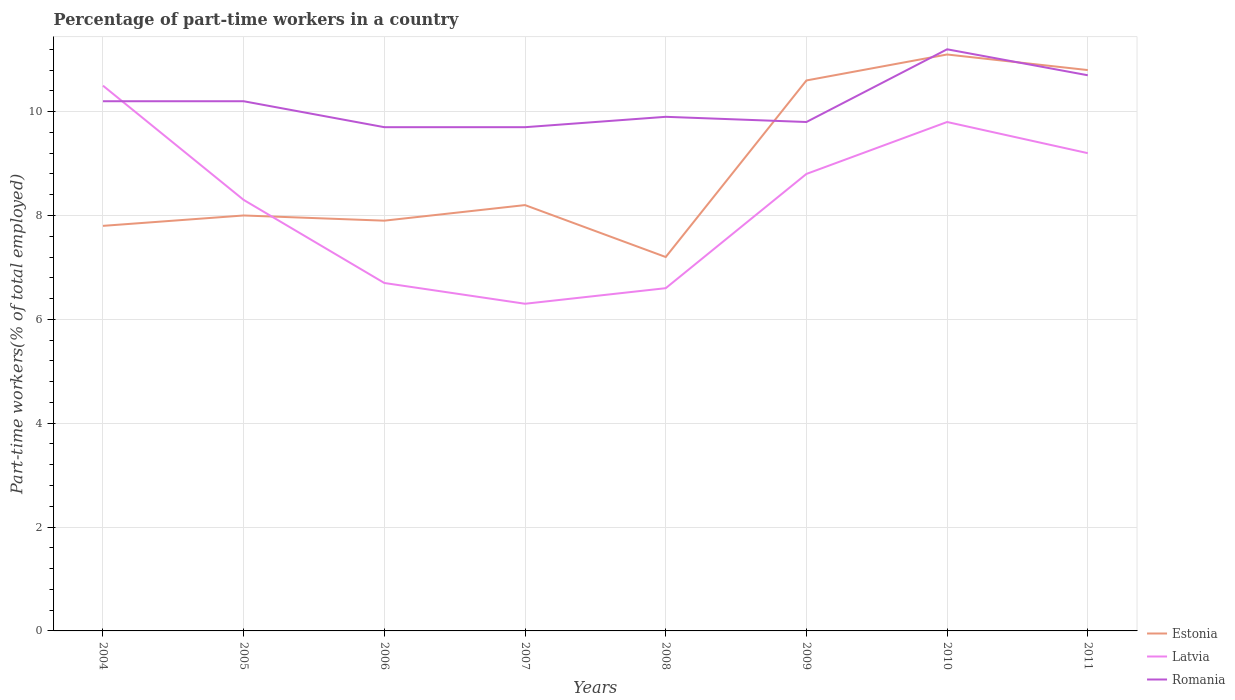Is the number of lines equal to the number of legend labels?
Your response must be concise. Yes. Across all years, what is the maximum percentage of part-time workers in Estonia?
Your answer should be very brief. 7.2. What is the total percentage of part-time workers in Romania in the graph?
Make the answer very short. 0.1. What is the difference between the highest and the second highest percentage of part-time workers in Romania?
Give a very brief answer. 1.5. What is the difference between the highest and the lowest percentage of part-time workers in Estonia?
Your answer should be compact. 3. Is the percentage of part-time workers in Latvia strictly greater than the percentage of part-time workers in Romania over the years?
Provide a succinct answer. No. How many lines are there?
Offer a terse response. 3. How many years are there in the graph?
Your response must be concise. 8. Are the values on the major ticks of Y-axis written in scientific E-notation?
Offer a very short reply. No. Does the graph contain grids?
Provide a short and direct response. Yes. How are the legend labels stacked?
Keep it short and to the point. Vertical. What is the title of the graph?
Provide a short and direct response. Percentage of part-time workers in a country. What is the label or title of the Y-axis?
Ensure brevity in your answer.  Part-time workers(% of total employed). What is the Part-time workers(% of total employed) of Estonia in 2004?
Give a very brief answer. 7.8. What is the Part-time workers(% of total employed) of Romania in 2004?
Your answer should be very brief. 10.2. What is the Part-time workers(% of total employed) of Latvia in 2005?
Give a very brief answer. 8.3. What is the Part-time workers(% of total employed) in Romania in 2005?
Your response must be concise. 10.2. What is the Part-time workers(% of total employed) in Estonia in 2006?
Give a very brief answer. 7.9. What is the Part-time workers(% of total employed) of Latvia in 2006?
Ensure brevity in your answer.  6.7. What is the Part-time workers(% of total employed) in Romania in 2006?
Ensure brevity in your answer.  9.7. What is the Part-time workers(% of total employed) in Estonia in 2007?
Give a very brief answer. 8.2. What is the Part-time workers(% of total employed) of Latvia in 2007?
Your response must be concise. 6.3. What is the Part-time workers(% of total employed) of Romania in 2007?
Provide a succinct answer. 9.7. What is the Part-time workers(% of total employed) of Estonia in 2008?
Make the answer very short. 7.2. What is the Part-time workers(% of total employed) of Latvia in 2008?
Offer a terse response. 6.6. What is the Part-time workers(% of total employed) in Romania in 2008?
Your response must be concise. 9.9. What is the Part-time workers(% of total employed) of Estonia in 2009?
Your response must be concise. 10.6. What is the Part-time workers(% of total employed) of Latvia in 2009?
Keep it short and to the point. 8.8. What is the Part-time workers(% of total employed) of Romania in 2009?
Your answer should be very brief. 9.8. What is the Part-time workers(% of total employed) in Estonia in 2010?
Your response must be concise. 11.1. What is the Part-time workers(% of total employed) in Latvia in 2010?
Ensure brevity in your answer.  9.8. What is the Part-time workers(% of total employed) of Romania in 2010?
Your answer should be very brief. 11.2. What is the Part-time workers(% of total employed) of Estonia in 2011?
Offer a terse response. 10.8. What is the Part-time workers(% of total employed) in Latvia in 2011?
Your response must be concise. 9.2. What is the Part-time workers(% of total employed) in Romania in 2011?
Offer a very short reply. 10.7. Across all years, what is the maximum Part-time workers(% of total employed) in Estonia?
Offer a terse response. 11.1. Across all years, what is the maximum Part-time workers(% of total employed) of Romania?
Your response must be concise. 11.2. Across all years, what is the minimum Part-time workers(% of total employed) of Estonia?
Make the answer very short. 7.2. Across all years, what is the minimum Part-time workers(% of total employed) of Latvia?
Provide a succinct answer. 6.3. Across all years, what is the minimum Part-time workers(% of total employed) of Romania?
Keep it short and to the point. 9.7. What is the total Part-time workers(% of total employed) in Estonia in the graph?
Offer a very short reply. 71.6. What is the total Part-time workers(% of total employed) of Latvia in the graph?
Offer a terse response. 66.2. What is the total Part-time workers(% of total employed) of Romania in the graph?
Offer a terse response. 81.4. What is the difference between the Part-time workers(% of total employed) in Estonia in 2004 and that in 2005?
Your response must be concise. -0.2. What is the difference between the Part-time workers(% of total employed) in Latvia in 2004 and that in 2005?
Provide a succinct answer. 2.2. What is the difference between the Part-time workers(% of total employed) of Romania in 2004 and that in 2006?
Provide a succinct answer. 0.5. What is the difference between the Part-time workers(% of total employed) in Estonia in 2004 and that in 2007?
Make the answer very short. -0.4. What is the difference between the Part-time workers(% of total employed) of Romania in 2004 and that in 2007?
Ensure brevity in your answer.  0.5. What is the difference between the Part-time workers(% of total employed) in Estonia in 2004 and that in 2009?
Offer a terse response. -2.8. What is the difference between the Part-time workers(% of total employed) in Latvia in 2004 and that in 2009?
Offer a very short reply. 1.7. What is the difference between the Part-time workers(% of total employed) in Romania in 2004 and that in 2009?
Make the answer very short. 0.4. What is the difference between the Part-time workers(% of total employed) in Estonia in 2004 and that in 2011?
Provide a succinct answer. -3. What is the difference between the Part-time workers(% of total employed) in Estonia in 2005 and that in 2006?
Your response must be concise. 0.1. What is the difference between the Part-time workers(% of total employed) in Latvia in 2005 and that in 2007?
Your answer should be compact. 2. What is the difference between the Part-time workers(% of total employed) of Estonia in 2005 and that in 2008?
Keep it short and to the point. 0.8. What is the difference between the Part-time workers(% of total employed) in Latvia in 2005 and that in 2008?
Offer a very short reply. 1.7. What is the difference between the Part-time workers(% of total employed) of Latvia in 2005 and that in 2009?
Keep it short and to the point. -0.5. What is the difference between the Part-time workers(% of total employed) of Romania in 2005 and that in 2009?
Your answer should be compact. 0.4. What is the difference between the Part-time workers(% of total employed) in Romania in 2005 and that in 2011?
Offer a very short reply. -0.5. What is the difference between the Part-time workers(% of total employed) of Latvia in 2006 and that in 2007?
Provide a succinct answer. 0.4. What is the difference between the Part-time workers(% of total employed) of Romania in 2006 and that in 2007?
Give a very brief answer. 0. What is the difference between the Part-time workers(% of total employed) of Estonia in 2006 and that in 2008?
Offer a terse response. 0.7. What is the difference between the Part-time workers(% of total employed) in Latvia in 2006 and that in 2008?
Give a very brief answer. 0.1. What is the difference between the Part-time workers(% of total employed) of Estonia in 2006 and that in 2009?
Ensure brevity in your answer.  -2.7. What is the difference between the Part-time workers(% of total employed) in Latvia in 2006 and that in 2009?
Your response must be concise. -2.1. What is the difference between the Part-time workers(% of total employed) of Romania in 2006 and that in 2009?
Your answer should be compact. -0.1. What is the difference between the Part-time workers(% of total employed) in Romania in 2006 and that in 2010?
Keep it short and to the point. -1.5. What is the difference between the Part-time workers(% of total employed) of Estonia in 2006 and that in 2011?
Keep it short and to the point. -2.9. What is the difference between the Part-time workers(% of total employed) of Estonia in 2007 and that in 2008?
Offer a terse response. 1. What is the difference between the Part-time workers(% of total employed) of Latvia in 2007 and that in 2008?
Your answer should be compact. -0.3. What is the difference between the Part-time workers(% of total employed) in Romania in 2007 and that in 2008?
Offer a very short reply. -0.2. What is the difference between the Part-time workers(% of total employed) of Latvia in 2007 and that in 2009?
Provide a short and direct response. -2.5. What is the difference between the Part-time workers(% of total employed) of Estonia in 2007 and that in 2010?
Your answer should be compact. -2.9. What is the difference between the Part-time workers(% of total employed) of Estonia in 2007 and that in 2011?
Keep it short and to the point. -2.6. What is the difference between the Part-time workers(% of total employed) of Estonia in 2008 and that in 2009?
Keep it short and to the point. -3.4. What is the difference between the Part-time workers(% of total employed) of Latvia in 2008 and that in 2009?
Offer a very short reply. -2.2. What is the difference between the Part-time workers(% of total employed) of Romania in 2008 and that in 2009?
Offer a very short reply. 0.1. What is the difference between the Part-time workers(% of total employed) in Romania in 2008 and that in 2010?
Provide a short and direct response. -1.3. What is the difference between the Part-time workers(% of total employed) of Latvia in 2008 and that in 2011?
Your answer should be compact. -2.6. What is the difference between the Part-time workers(% of total employed) in Estonia in 2009 and that in 2010?
Offer a terse response. -0.5. What is the difference between the Part-time workers(% of total employed) of Romania in 2009 and that in 2010?
Offer a very short reply. -1.4. What is the difference between the Part-time workers(% of total employed) of Estonia in 2009 and that in 2011?
Keep it short and to the point. -0.2. What is the difference between the Part-time workers(% of total employed) in Estonia in 2010 and that in 2011?
Provide a succinct answer. 0.3. What is the difference between the Part-time workers(% of total employed) of Romania in 2010 and that in 2011?
Provide a succinct answer. 0.5. What is the difference between the Part-time workers(% of total employed) of Estonia in 2004 and the Part-time workers(% of total employed) of Latvia in 2005?
Your answer should be compact. -0.5. What is the difference between the Part-time workers(% of total employed) of Estonia in 2004 and the Part-time workers(% of total employed) of Romania in 2005?
Provide a succinct answer. -2.4. What is the difference between the Part-time workers(% of total employed) in Latvia in 2004 and the Part-time workers(% of total employed) in Romania in 2005?
Offer a terse response. 0.3. What is the difference between the Part-time workers(% of total employed) of Estonia in 2004 and the Part-time workers(% of total employed) of Latvia in 2006?
Keep it short and to the point. 1.1. What is the difference between the Part-time workers(% of total employed) in Estonia in 2004 and the Part-time workers(% of total employed) in Romania in 2007?
Your answer should be very brief. -1.9. What is the difference between the Part-time workers(% of total employed) in Estonia in 2004 and the Part-time workers(% of total employed) in Latvia in 2009?
Give a very brief answer. -1. What is the difference between the Part-time workers(% of total employed) of Estonia in 2004 and the Part-time workers(% of total employed) of Romania in 2009?
Your response must be concise. -2. What is the difference between the Part-time workers(% of total employed) of Latvia in 2004 and the Part-time workers(% of total employed) of Romania in 2009?
Provide a succinct answer. 0.7. What is the difference between the Part-time workers(% of total employed) of Estonia in 2004 and the Part-time workers(% of total employed) of Latvia in 2010?
Offer a terse response. -2. What is the difference between the Part-time workers(% of total employed) in Estonia in 2004 and the Part-time workers(% of total employed) in Romania in 2010?
Keep it short and to the point. -3.4. What is the difference between the Part-time workers(% of total employed) of Estonia in 2004 and the Part-time workers(% of total employed) of Latvia in 2011?
Keep it short and to the point. -1.4. What is the difference between the Part-time workers(% of total employed) in Estonia in 2005 and the Part-time workers(% of total employed) in Latvia in 2006?
Your answer should be very brief. 1.3. What is the difference between the Part-time workers(% of total employed) in Latvia in 2005 and the Part-time workers(% of total employed) in Romania in 2006?
Your answer should be compact. -1.4. What is the difference between the Part-time workers(% of total employed) in Estonia in 2005 and the Part-time workers(% of total employed) in Latvia in 2007?
Offer a very short reply. 1.7. What is the difference between the Part-time workers(% of total employed) of Estonia in 2005 and the Part-time workers(% of total employed) of Romania in 2008?
Provide a short and direct response. -1.9. What is the difference between the Part-time workers(% of total employed) in Estonia in 2005 and the Part-time workers(% of total employed) in Latvia in 2009?
Make the answer very short. -0.8. What is the difference between the Part-time workers(% of total employed) of Estonia in 2005 and the Part-time workers(% of total employed) of Romania in 2010?
Keep it short and to the point. -3.2. What is the difference between the Part-time workers(% of total employed) of Latvia in 2005 and the Part-time workers(% of total employed) of Romania in 2010?
Offer a terse response. -2.9. What is the difference between the Part-time workers(% of total employed) in Estonia in 2006 and the Part-time workers(% of total employed) in Latvia in 2007?
Provide a short and direct response. 1.6. What is the difference between the Part-time workers(% of total employed) of Estonia in 2006 and the Part-time workers(% of total employed) of Romania in 2007?
Provide a succinct answer. -1.8. What is the difference between the Part-time workers(% of total employed) in Estonia in 2006 and the Part-time workers(% of total employed) in Latvia in 2008?
Your answer should be very brief. 1.3. What is the difference between the Part-time workers(% of total employed) in Estonia in 2006 and the Part-time workers(% of total employed) in Romania in 2008?
Make the answer very short. -2. What is the difference between the Part-time workers(% of total employed) in Latvia in 2006 and the Part-time workers(% of total employed) in Romania in 2008?
Keep it short and to the point. -3.2. What is the difference between the Part-time workers(% of total employed) in Estonia in 2006 and the Part-time workers(% of total employed) in Latvia in 2009?
Offer a very short reply. -0.9. What is the difference between the Part-time workers(% of total employed) of Estonia in 2006 and the Part-time workers(% of total employed) of Romania in 2010?
Your response must be concise. -3.3. What is the difference between the Part-time workers(% of total employed) of Latvia in 2006 and the Part-time workers(% of total employed) of Romania in 2010?
Offer a terse response. -4.5. What is the difference between the Part-time workers(% of total employed) of Estonia in 2006 and the Part-time workers(% of total employed) of Latvia in 2011?
Offer a terse response. -1.3. What is the difference between the Part-time workers(% of total employed) in Latvia in 2006 and the Part-time workers(% of total employed) in Romania in 2011?
Provide a short and direct response. -4. What is the difference between the Part-time workers(% of total employed) of Estonia in 2007 and the Part-time workers(% of total employed) of Latvia in 2008?
Offer a very short reply. 1.6. What is the difference between the Part-time workers(% of total employed) in Latvia in 2007 and the Part-time workers(% of total employed) in Romania in 2008?
Offer a very short reply. -3.6. What is the difference between the Part-time workers(% of total employed) in Estonia in 2007 and the Part-time workers(% of total employed) in Romania in 2009?
Your response must be concise. -1.6. What is the difference between the Part-time workers(% of total employed) in Estonia in 2007 and the Part-time workers(% of total employed) in Romania in 2011?
Keep it short and to the point. -2.5. What is the difference between the Part-time workers(% of total employed) of Estonia in 2008 and the Part-time workers(% of total employed) of Romania in 2009?
Provide a short and direct response. -2.6. What is the difference between the Part-time workers(% of total employed) in Latvia in 2008 and the Part-time workers(% of total employed) in Romania in 2009?
Provide a short and direct response. -3.2. What is the difference between the Part-time workers(% of total employed) of Estonia in 2008 and the Part-time workers(% of total employed) of Latvia in 2010?
Ensure brevity in your answer.  -2.6. What is the difference between the Part-time workers(% of total employed) in Estonia in 2008 and the Part-time workers(% of total employed) in Latvia in 2011?
Ensure brevity in your answer.  -2. What is the difference between the Part-time workers(% of total employed) of Estonia in 2009 and the Part-time workers(% of total employed) of Romania in 2010?
Provide a short and direct response. -0.6. What is the difference between the Part-time workers(% of total employed) in Latvia in 2009 and the Part-time workers(% of total employed) in Romania in 2010?
Offer a terse response. -2.4. What is the difference between the Part-time workers(% of total employed) in Estonia in 2009 and the Part-time workers(% of total employed) in Latvia in 2011?
Offer a very short reply. 1.4. What is the difference between the Part-time workers(% of total employed) in Estonia in 2009 and the Part-time workers(% of total employed) in Romania in 2011?
Your answer should be compact. -0.1. What is the difference between the Part-time workers(% of total employed) in Latvia in 2009 and the Part-time workers(% of total employed) in Romania in 2011?
Provide a succinct answer. -1.9. What is the difference between the Part-time workers(% of total employed) of Latvia in 2010 and the Part-time workers(% of total employed) of Romania in 2011?
Keep it short and to the point. -0.9. What is the average Part-time workers(% of total employed) of Estonia per year?
Offer a terse response. 8.95. What is the average Part-time workers(% of total employed) of Latvia per year?
Your answer should be very brief. 8.28. What is the average Part-time workers(% of total employed) in Romania per year?
Provide a succinct answer. 10.18. In the year 2004, what is the difference between the Part-time workers(% of total employed) of Estonia and Part-time workers(% of total employed) of Latvia?
Ensure brevity in your answer.  -2.7. In the year 2004, what is the difference between the Part-time workers(% of total employed) in Latvia and Part-time workers(% of total employed) in Romania?
Ensure brevity in your answer.  0.3. In the year 2007, what is the difference between the Part-time workers(% of total employed) of Estonia and Part-time workers(% of total employed) of Romania?
Your answer should be compact. -1.5. In the year 2008, what is the difference between the Part-time workers(% of total employed) of Estonia and Part-time workers(% of total employed) of Romania?
Give a very brief answer. -2.7. In the year 2009, what is the difference between the Part-time workers(% of total employed) of Estonia and Part-time workers(% of total employed) of Latvia?
Give a very brief answer. 1.8. In the year 2009, what is the difference between the Part-time workers(% of total employed) in Estonia and Part-time workers(% of total employed) in Romania?
Offer a terse response. 0.8. In the year 2010, what is the difference between the Part-time workers(% of total employed) in Estonia and Part-time workers(% of total employed) in Latvia?
Your answer should be very brief. 1.3. In the year 2010, what is the difference between the Part-time workers(% of total employed) in Estonia and Part-time workers(% of total employed) in Romania?
Make the answer very short. -0.1. In the year 2010, what is the difference between the Part-time workers(% of total employed) in Latvia and Part-time workers(% of total employed) in Romania?
Provide a succinct answer. -1.4. In the year 2011, what is the difference between the Part-time workers(% of total employed) of Estonia and Part-time workers(% of total employed) of Latvia?
Offer a terse response. 1.6. In the year 2011, what is the difference between the Part-time workers(% of total employed) in Estonia and Part-time workers(% of total employed) in Romania?
Ensure brevity in your answer.  0.1. In the year 2011, what is the difference between the Part-time workers(% of total employed) of Latvia and Part-time workers(% of total employed) of Romania?
Your answer should be compact. -1.5. What is the ratio of the Part-time workers(% of total employed) in Estonia in 2004 to that in 2005?
Your response must be concise. 0.97. What is the ratio of the Part-time workers(% of total employed) in Latvia in 2004 to that in 2005?
Keep it short and to the point. 1.27. What is the ratio of the Part-time workers(% of total employed) in Romania in 2004 to that in 2005?
Ensure brevity in your answer.  1. What is the ratio of the Part-time workers(% of total employed) in Estonia in 2004 to that in 2006?
Your answer should be compact. 0.99. What is the ratio of the Part-time workers(% of total employed) of Latvia in 2004 to that in 2006?
Provide a short and direct response. 1.57. What is the ratio of the Part-time workers(% of total employed) in Romania in 2004 to that in 2006?
Provide a succinct answer. 1.05. What is the ratio of the Part-time workers(% of total employed) of Estonia in 2004 to that in 2007?
Your answer should be compact. 0.95. What is the ratio of the Part-time workers(% of total employed) of Latvia in 2004 to that in 2007?
Your answer should be very brief. 1.67. What is the ratio of the Part-time workers(% of total employed) in Romania in 2004 to that in 2007?
Your answer should be very brief. 1.05. What is the ratio of the Part-time workers(% of total employed) in Latvia in 2004 to that in 2008?
Give a very brief answer. 1.59. What is the ratio of the Part-time workers(% of total employed) of Romania in 2004 to that in 2008?
Offer a terse response. 1.03. What is the ratio of the Part-time workers(% of total employed) in Estonia in 2004 to that in 2009?
Provide a succinct answer. 0.74. What is the ratio of the Part-time workers(% of total employed) in Latvia in 2004 to that in 2009?
Offer a terse response. 1.19. What is the ratio of the Part-time workers(% of total employed) of Romania in 2004 to that in 2009?
Your answer should be compact. 1.04. What is the ratio of the Part-time workers(% of total employed) of Estonia in 2004 to that in 2010?
Provide a succinct answer. 0.7. What is the ratio of the Part-time workers(% of total employed) in Latvia in 2004 to that in 2010?
Make the answer very short. 1.07. What is the ratio of the Part-time workers(% of total employed) in Romania in 2004 to that in 2010?
Make the answer very short. 0.91. What is the ratio of the Part-time workers(% of total employed) of Estonia in 2004 to that in 2011?
Make the answer very short. 0.72. What is the ratio of the Part-time workers(% of total employed) in Latvia in 2004 to that in 2011?
Your answer should be compact. 1.14. What is the ratio of the Part-time workers(% of total employed) in Romania in 2004 to that in 2011?
Provide a short and direct response. 0.95. What is the ratio of the Part-time workers(% of total employed) of Estonia in 2005 to that in 2006?
Keep it short and to the point. 1.01. What is the ratio of the Part-time workers(% of total employed) of Latvia in 2005 to that in 2006?
Provide a succinct answer. 1.24. What is the ratio of the Part-time workers(% of total employed) in Romania in 2005 to that in 2006?
Offer a terse response. 1.05. What is the ratio of the Part-time workers(% of total employed) of Estonia in 2005 to that in 2007?
Offer a very short reply. 0.98. What is the ratio of the Part-time workers(% of total employed) of Latvia in 2005 to that in 2007?
Offer a terse response. 1.32. What is the ratio of the Part-time workers(% of total employed) in Romania in 2005 to that in 2007?
Ensure brevity in your answer.  1.05. What is the ratio of the Part-time workers(% of total employed) of Estonia in 2005 to that in 2008?
Give a very brief answer. 1.11. What is the ratio of the Part-time workers(% of total employed) of Latvia in 2005 to that in 2008?
Provide a succinct answer. 1.26. What is the ratio of the Part-time workers(% of total employed) of Romania in 2005 to that in 2008?
Keep it short and to the point. 1.03. What is the ratio of the Part-time workers(% of total employed) in Estonia in 2005 to that in 2009?
Make the answer very short. 0.75. What is the ratio of the Part-time workers(% of total employed) of Latvia in 2005 to that in 2009?
Provide a succinct answer. 0.94. What is the ratio of the Part-time workers(% of total employed) in Romania in 2005 to that in 2009?
Make the answer very short. 1.04. What is the ratio of the Part-time workers(% of total employed) of Estonia in 2005 to that in 2010?
Keep it short and to the point. 0.72. What is the ratio of the Part-time workers(% of total employed) of Latvia in 2005 to that in 2010?
Your answer should be compact. 0.85. What is the ratio of the Part-time workers(% of total employed) in Romania in 2005 to that in 2010?
Offer a very short reply. 0.91. What is the ratio of the Part-time workers(% of total employed) of Estonia in 2005 to that in 2011?
Ensure brevity in your answer.  0.74. What is the ratio of the Part-time workers(% of total employed) of Latvia in 2005 to that in 2011?
Make the answer very short. 0.9. What is the ratio of the Part-time workers(% of total employed) of Romania in 2005 to that in 2011?
Keep it short and to the point. 0.95. What is the ratio of the Part-time workers(% of total employed) of Estonia in 2006 to that in 2007?
Your response must be concise. 0.96. What is the ratio of the Part-time workers(% of total employed) of Latvia in 2006 to that in 2007?
Offer a terse response. 1.06. What is the ratio of the Part-time workers(% of total employed) of Estonia in 2006 to that in 2008?
Make the answer very short. 1.1. What is the ratio of the Part-time workers(% of total employed) in Latvia in 2006 to that in 2008?
Your response must be concise. 1.02. What is the ratio of the Part-time workers(% of total employed) in Romania in 2006 to that in 2008?
Offer a terse response. 0.98. What is the ratio of the Part-time workers(% of total employed) in Estonia in 2006 to that in 2009?
Your answer should be very brief. 0.75. What is the ratio of the Part-time workers(% of total employed) in Latvia in 2006 to that in 2009?
Your answer should be compact. 0.76. What is the ratio of the Part-time workers(% of total employed) in Romania in 2006 to that in 2009?
Make the answer very short. 0.99. What is the ratio of the Part-time workers(% of total employed) in Estonia in 2006 to that in 2010?
Keep it short and to the point. 0.71. What is the ratio of the Part-time workers(% of total employed) of Latvia in 2006 to that in 2010?
Keep it short and to the point. 0.68. What is the ratio of the Part-time workers(% of total employed) in Romania in 2006 to that in 2010?
Ensure brevity in your answer.  0.87. What is the ratio of the Part-time workers(% of total employed) in Estonia in 2006 to that in 2011?
Provide a succinct answer. 0.73. What is the ratio of the Part-time workers(% of total employed) of Latvia in 2006 to that in 2011?
Keep it short and to the point. 0.73. What is the ratio of the Part-time workers(% of total employed) of Romania in 2006 to that in 2011?
Offer a terse response. 0.91. What is the ratio of the Part-time workers(% of total employed) in Estonia in 2007 to that in 2008?
Provide a short and direct response. 1.14. What is the ratio of the Part-time workers(% of total employed) in Latvia in 2007 to that in 2008?
Offer a very short reply. 0.95. What is the ratio of the Part-time workers(% of total employed) in Romania in 2007 to that in 2008?
Provide a succinct answer. 0.98. What is the ratio of the Part-time workers(% of total employed) of Estonia in 2007 to that in 2009?
Your answer should be very brief. 0.77. What is the ratio of the Part-time workers(% of total employed) in Latvia in 2007 to that in 2009?
Make the answer very short. 0.72. What is the ratio of the Part-time workers(% of total employed) in Romania in 2007 to that in 2009?
Your response must be concise. 0.99. What is the ratio of the Part-time workers(% of total employed) in Estonia in 2007 to that in 2010?
Offer a terse response. 0.74. What is the ratio of the Part-time workers(% of total employed) of Latvia in 2007 to that in 2010?
Provide a succinct answer. 0.64. What is the ratio of the Part-time workers(% of total employed) in Romania in 2007 to that in 2010?
Keep it short and to the point. 0.87. What is the ratio of the Part-time workers(% of total employed) in Estonia in 2007 to that in 2011?
Provide a short and direct response. 0.76. What is the ratio of the Part-time workers(% of total employed) in Latvia in 2007 to that in 2011?
Provide a short and direct response. 0.68. What is the ratio of the Part-time workers(% of total employed) of Romania in 2007 to that in 2011?
Offer a terse response. 0.91. What is the ratio of the Part-time workers(% of total employed) in Estonia in 2008 to that in 2009?
Offer a very short reply. 0.68. What is the ratio of the Part-time workers(% of total employed) in Latvia in 2008 to that in 2009?
Keep it short and to the point. 0.75. What is the ratio of the Part-time workers(% of total employed) in Romania in 2008 to that in 2009?
Offer a terse response. 1.01. What is the ratio of the Part-time workers(% of total employed) in Estonia in 2008 to that in 2010?
Your answer should be very brief. 0.65. What is the ratio of the Part-time workers(% of total employed) in Latvia in 2008 to that in 2010?
Your response must be concise. 0.67. What is the ratio of the Part-time workers(% of total employed) in Romania in 2008 to that in 2010?
Your answer should be compact. 0.88. What is the ratio of the Part-time workers(% of total employed) of Latvia in 2008 to that in 2011?
Keep it short and to the point. 0.72. What is the ratio of the Part-time workers(% of total employed) of Romania in 2008 to that in 2011?
Ensure brevity in your answer.  0.93. What is the ratio of the Part-time workers(% of total employed) of Estonia in 2009 to that in 2010?
Offer a terse response. 0.95. What is the ratio of the Part-time workers(% of total employed) of Latvia in 2009 to that in 2010?
Your answer should be very brief. 0.9. What is the ratio of the Part-time workers(% of total employed) of Romania in 2009 to that in 2010?
Provide a short and direct response. 0.88. What is the ratio of the Part-time workers(% of total employed) in Estonia in 2009 to that in 2011?
Your answer should be compact. 0.98. What is the ratio of the Part-time workers(% of total employed) in Latvia in 2009 to that in 2011?
Offer a very short reply. 0.96. What is the ratio of the Part-time workers(% of total employed) in Romania in 2009 to that in 2011?
Keep it short and to the point. 0.92. What is the ratio of the Part-time workers(% of total employed) of Estonia in 2010 to that in 2011?
Offer a very short reply. 1.03. What is the ratio of the Part-time workers(% of total employed) of Latvia in 2010 to that in 2011?
Give a very brief answer. 1.07. What is the ratio of the Part-time workers(% of total employed) in Romania in 2010 to that in 2011?
Keep it short and to the point. 1.05. What is the difference between the highest and the second highest Part-time workers(% of total employed) of Latvia?
Your answer should be very brief. 0.7. What is the difference between the highest and the second highest Part-time workers(% of total employed) in Romania?
Provide a short and direct response. 0.5. What is the difference between the highest and the lowest Part-time workers(% of total employed) of Romania?
Make the answer very short. 1.5. 